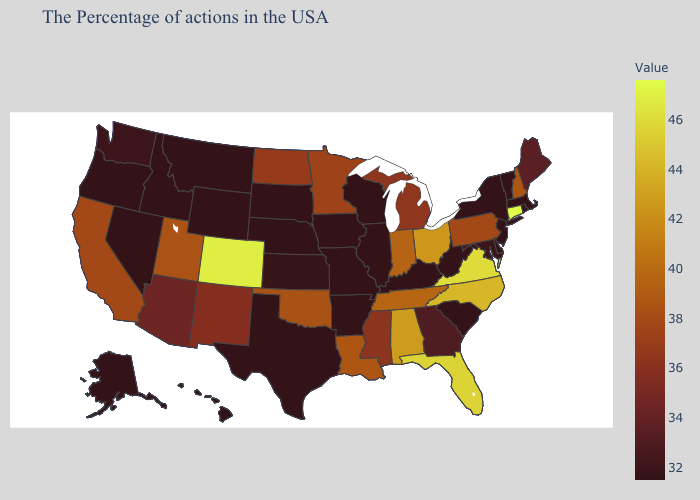Does Oklahoma have the lowest value in the USA?
Quick response, please. No. Does the map have missing data?
Quick response, please. No. Among the states that border Indiana , which have the highest value?
Concise answer only. Ohio. Does Kentucky have the lowest value in the South?
Quick response, please. Yes. Is the legend a continuous bar?
Quick response, please. Yes. Does the map have missing data?
Short answer required. No. 